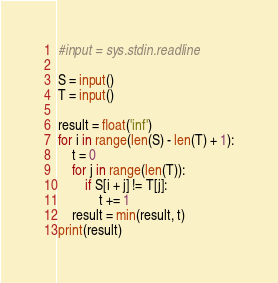Convert code to text. <code><loc_0><loc_0><loc_500><loc_500><_Python_>#input = sys.stdin.readline
 
S = input()
T = input()
 
result = float('inf')
for i in range(len(S) - len(T) + 1):
    t = 0
    for j in range(len(T)):
        if S[i + j] != T[j]:
            t += 1
    result = min(result, t)
print(result)</code> 